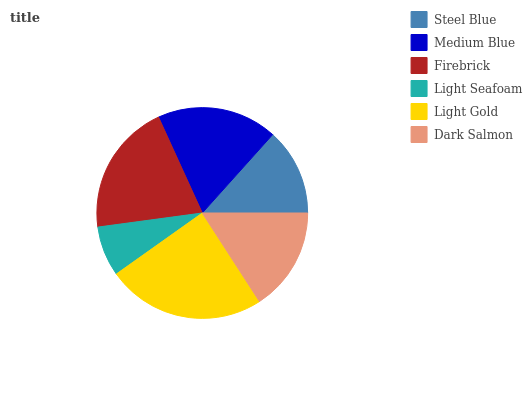Is Light Seafoam the minimum?
Answer yes or no. Yes. Is Light Gold the maximum?
Answer yes or no. Yes. Is Medium Blue the minimum?
Answer yes or no. No. Is Medium Blue the maximum?
Answer yes or no. No. Is Medium Blue greater than Steel Blue?
Answer yes or no. Yes. Is Steel Blue less than Medium Blue?
Answer yes or no. Yes. Is Steel Blue greater than Medium Blue?
Answer yes or no. No. Is Medium Blue less than Steel Blue?
Answer yes or no. No. Is Medium Blue the high median?
Answer yes or no. Yes. Is Dark Salmon the low median?
Answer yes or no. Yes. Is Dark Salmon the high median?
Answer yes or no. No. Is Medium Blue the low median?
Answer yes or no. No. 